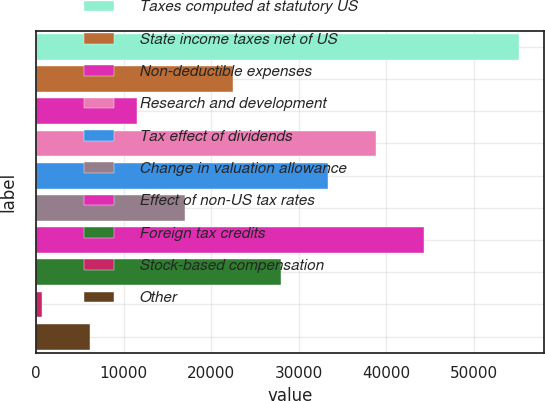Convert chart. <chart><loc_0><loc_0><loc_500><loc_500><bar_chart><fcel>Taxes computed at statutory US<fcel>State income taxes net of US<fcel>Non-deductible expenses<fcel>Research and development<fcel>Tax effect of dividends<fcel>Change in valuation allowance<fcel>Effect of non-US tax rates<fcel>Foreign tax credits<fcel>Stock-based compensation<fcel>Other<nl><fcel>55249<fcel>22475.8<fcel>11551.4<fcel>38862.4<fcel>33400.2<fcel>17013.6<fcel>44324.6<fcel>27938<fcel>627<fcel>6089.2<nl></chart> 